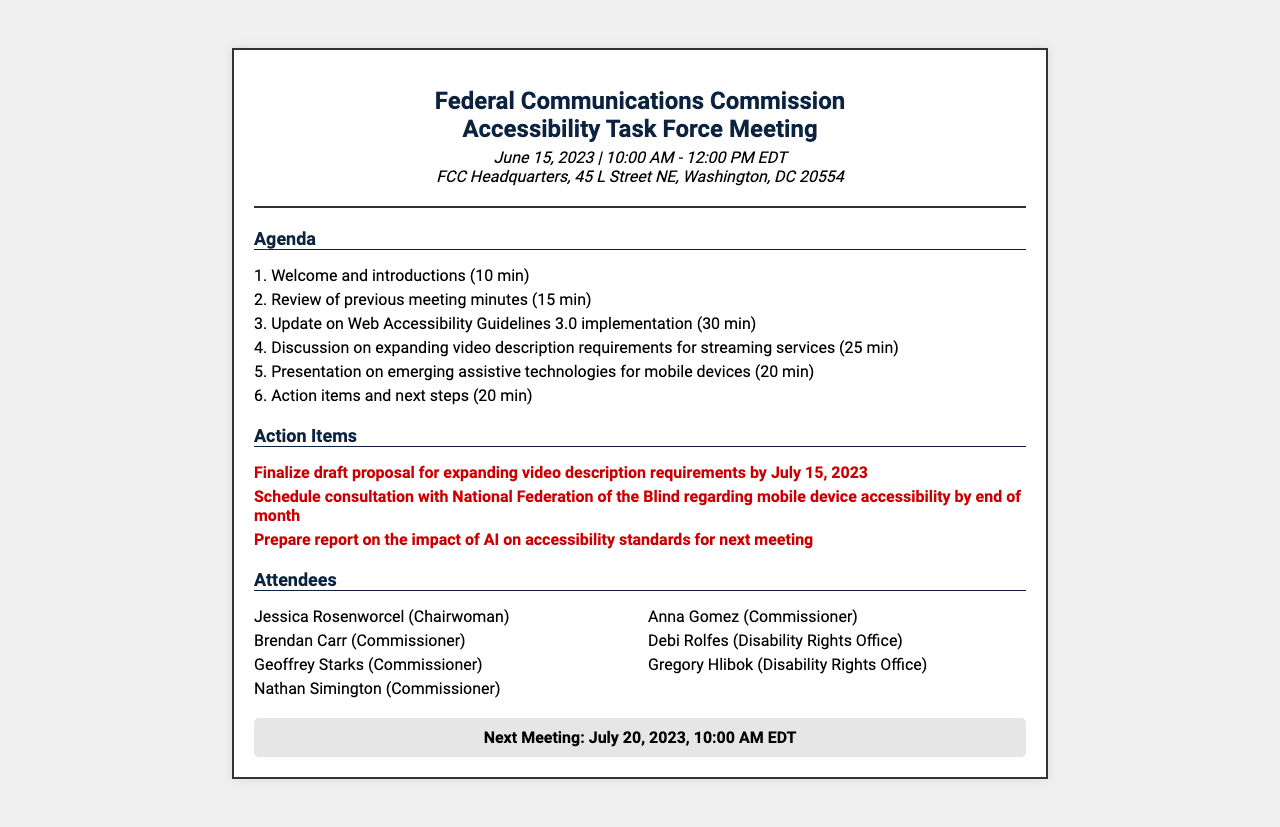What is the date of the meeting? The meeting is scheduled for June 15, 2023, as stated in the document.
Answer: June 15, 2023 Who is the chairwoman of the task force? The document lists Jessica Rosenworcel as the chairwoman.
Answer: Jessica Rosenworcel How long is the discussion on expanding video description requirements scheduled for? The agenda specifies that the discussion will take 25 minutes.
Answer: 25 min What is the first action item mentioned? The first action item listed is to finalize the draft proposal for expanding video description requirements.
Answer: Finalize draft proposal for expanding video description requirements by July 15, 2023 When is the next meeting scheduled? The document states that the next meeting will be on July 20, 2023.
Answer: July 20, 2023 How many attendees are listed in the document? The attendees section lists 7 individuals who attended the meeting.
Answer: 7 What is the time duration allocated for the update on Web Accessibility Guidelines 3.0 implementation? The agenda allocates 30 minutes for this update.
Answer: 30 min 